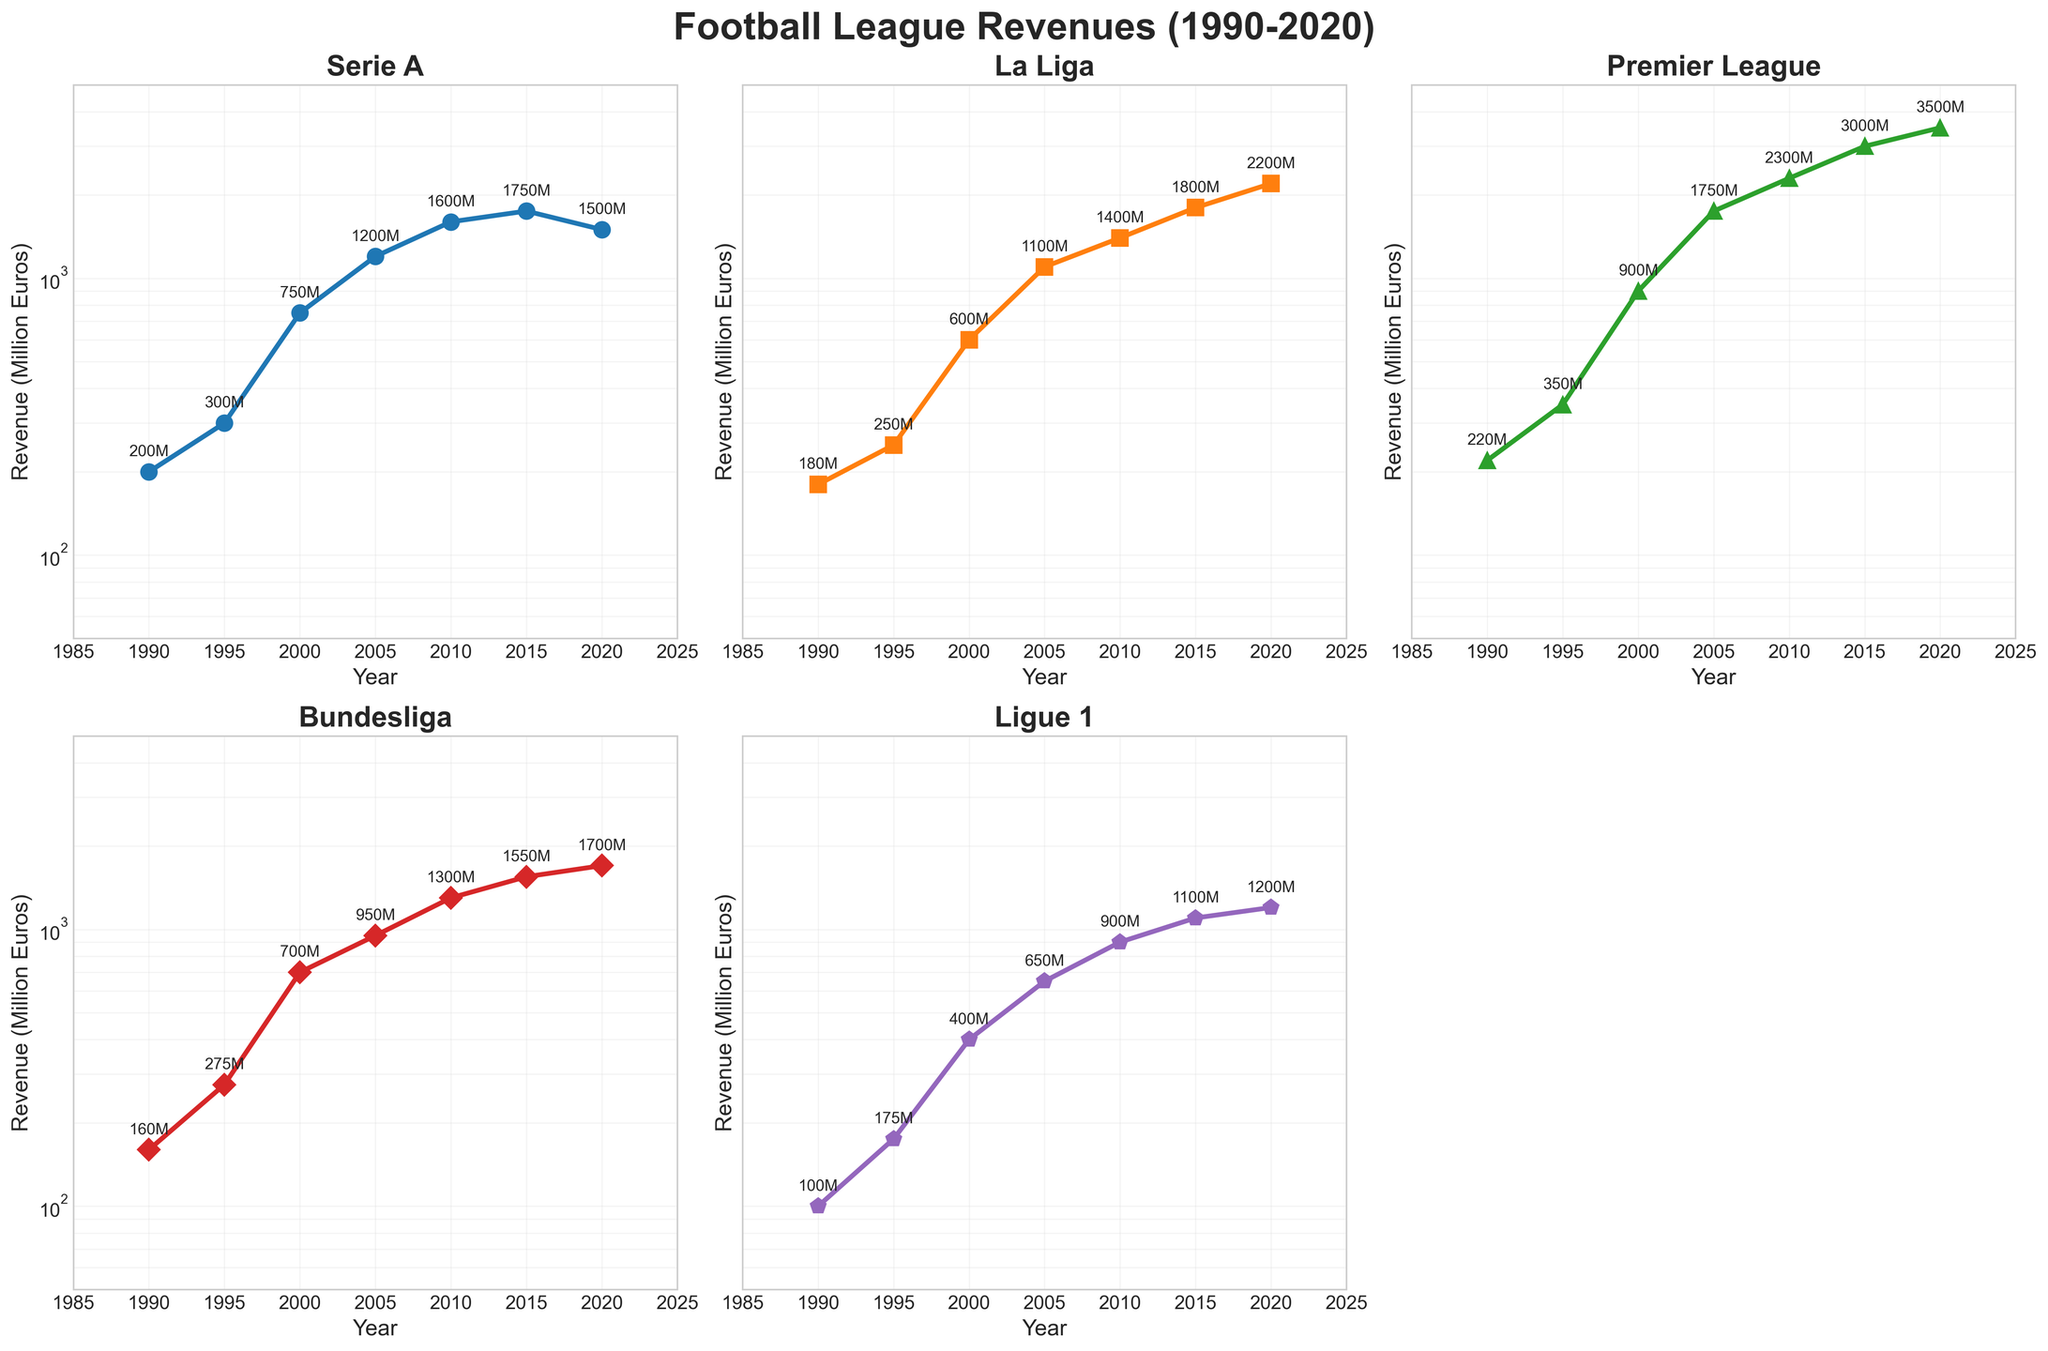What is the title of the plot? The title of the plot is displayed at the top and reads "Football League Revenues (1990-2020)".
Answer: Football League Revenues (1990-2020) What is the revenue of the Premier League in 2020? Look at the Premier League subplot and check the data point corresponding to the year 2020. The annotation next to the point reads "3500M".
Answer: 3500 million euros Which league had the highest revenue in 2005? Compare the data points for all leagues in 2005. The Premier League subplot shows the highest value which is annotated as "1750M".
Answer: Premier League Which league experienced the highest revenue drop between 2015 and 2020? Calculate the difference in revenue for each league between 2015 and 2020. Serie A shows a drop from 1750 million euros to 1500 million euros, a difference of 250 million euros, which is the largest drop among the leagues.
Answer: Serie A How many subplots are there in the figure? Count the number of subplots present in the figure. There are 5 subplots, one for each league, with the sixth subplot intentionally removed.
Answer: 5 What is the revenue of Ligue 1 in 2000? Look at the Ligue 1 subplot and check the data point corresponding to the year 2000. The annotation next to the point reads "400M".
Answer: 400 million euros Which league had the lowest revenue in 1990, and what was it? Review the revenue figures for all leagues in 1990. The subplot for Ligue 1 shows the lowest value, annotated as "100M".
Answer: Ligue 1, 100 million euros What trend can be observed for La Liga's revenue from 1990 to 2020? Observe the data points on La Liga's subplot from 1990 to 2020. The revenue consistently increases from 180 million euros in 1990 to 2200 million euros in 2020.
Answer: Continuous increase Between which two consecutive years did Bundesliga's revenue grow the most? Compare the growth in revenue between each pair of consecutive years for Bundesliga. The largest growth is between 1995 and 2000, from 275 million euros to 700 million euros, a difference of 425 million euros.
Answer: 1995 and 2000 What is the difference in revenue between Serie A and Bundesliga in 2010? Look at the data points for both leagues in 2010. Serie A has 1600 million euros and Bundesliga has 1300 million euros. The difference is 1600 - 1300 = 300 million euros.
Answer: 300 million euros 